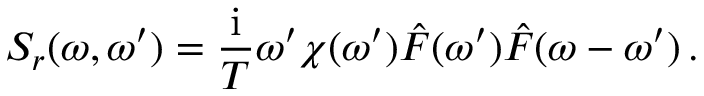<formula> <loc_0><loc_0><loc_500><loc_500>S _ { r } ( \omega , \omega ^ { \prime } ) = \frac { i } { T } \omega ^ { \prime } \chi ( \omega ^ { \prime } ) \hat { F } ( \omega ^ { \prime } ) \hat { F } ( \omega - \omega ^ { \prime } ) \, .</formula> 